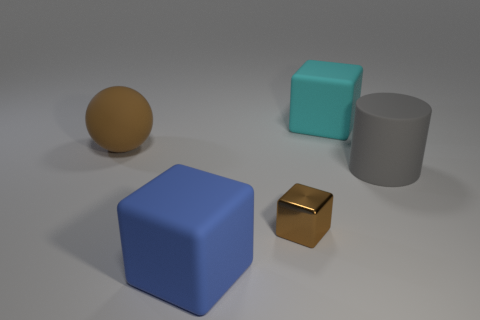What might be the relative sizes of the objects if we were to compare them? In comparison, the blue cube is the largest object, followed by the rubber sphere, which seems moderately large. The teal cube is smaller than both the blue cube and the rubber sphere, while the tiny brown block is the smallest object on the surface. 